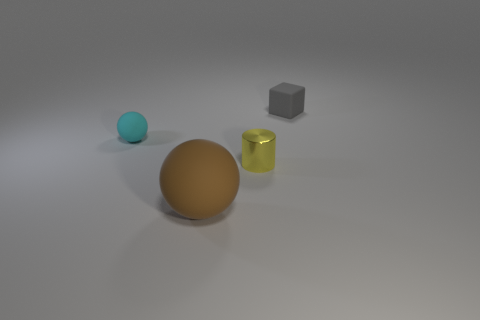Add 1 tiny cyan rubber objects. How many objects exist? 5 Subtract all cylinders. How many objects are left? 3 Add 1 rubber spheres. How many rubber spheres exist? 3 Subtract 0 purple cylinders. How many objects are left? 4 Subtract all tiny yellow objects. Subtract all yellow things. How many objects are left? 2 Add 2 gray cubes. How many gray cubes are left? 3 